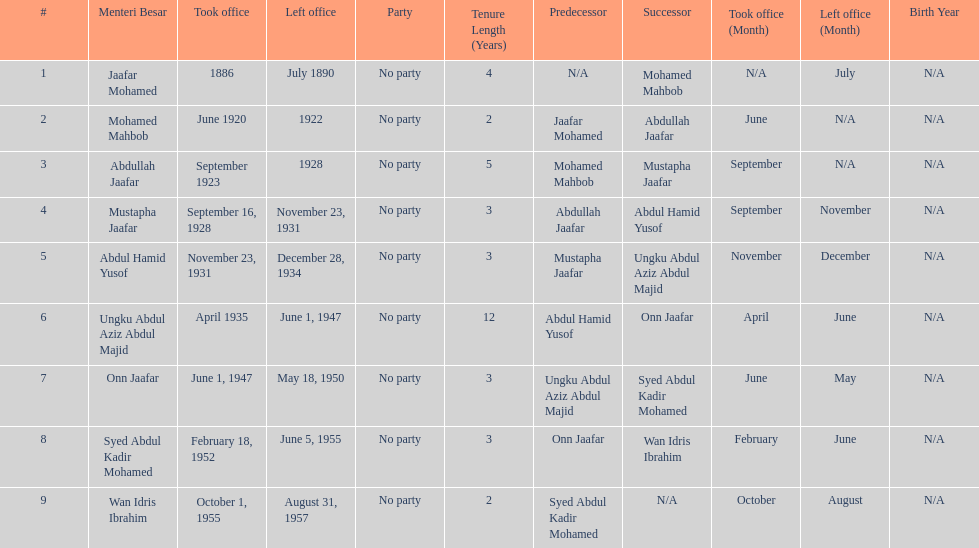Who took office after abdullah jaafar? Mustapha Jaafar. 